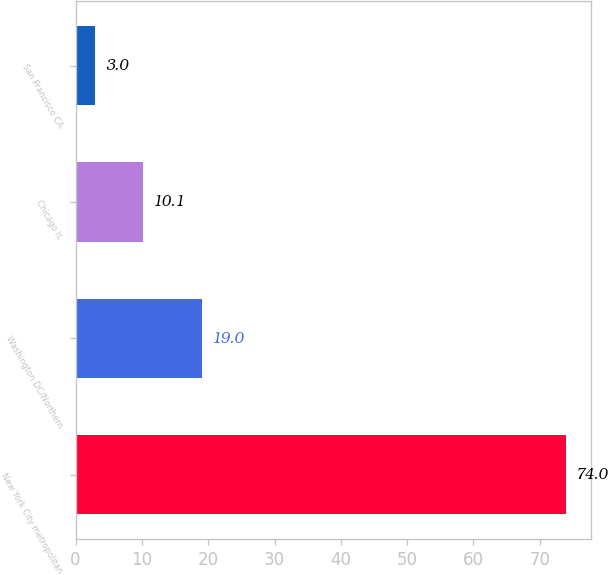Convert chart to OTSL. <chart><loc_0><loc_0><loc_500><loc_500><bar_chart><fcel>New York City metropolitan<fcel>Washington DC/Northern<fcel>Chicago IL<fcel>San Francisco CA<nl><fcel>74<fcel>19<fcel>10.1<fcel>3<nl></chart> 